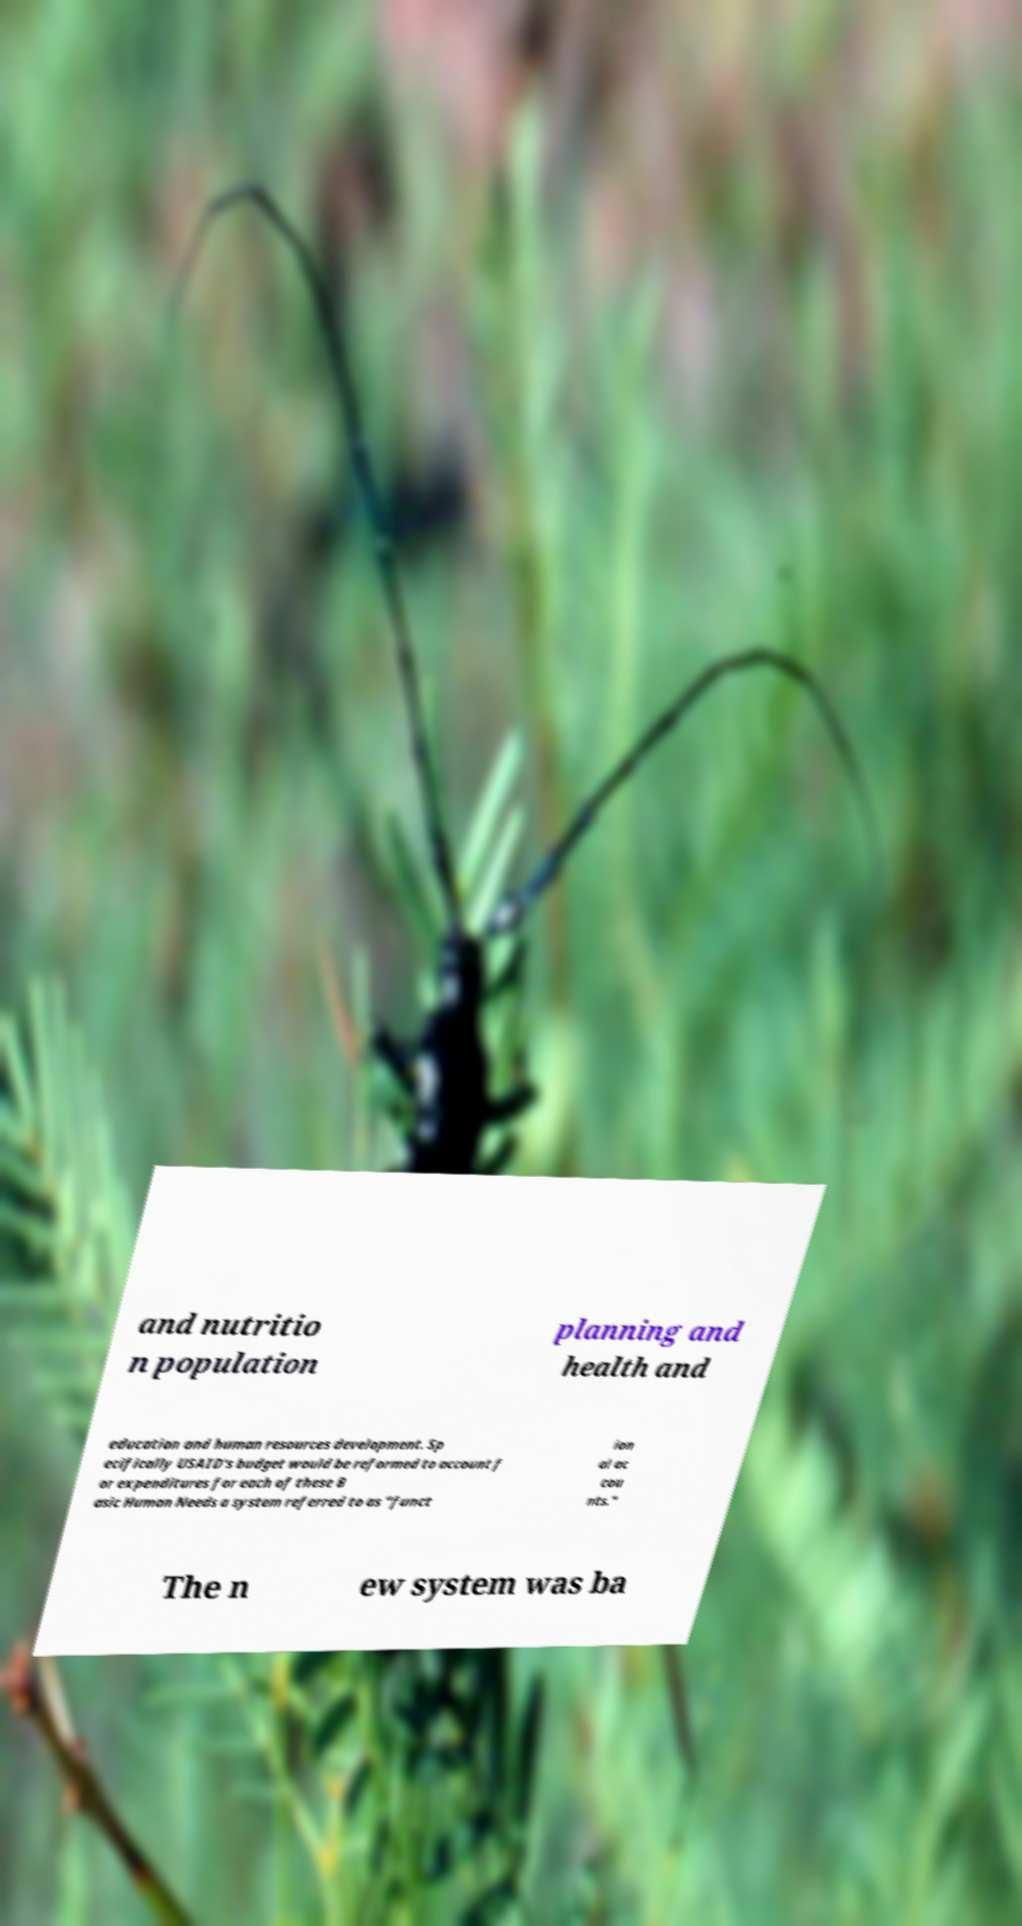For documentation purposes, I need the text within this image transcribed. Could you provide that? and nutritio n population planning and health and education and human resources development. Sp ecifically USAID's budget would be reformed to account f or expenditures for each of these B asic Human Needs a system referred to as "funct ion al ac cou nts." The n ew system was ba 